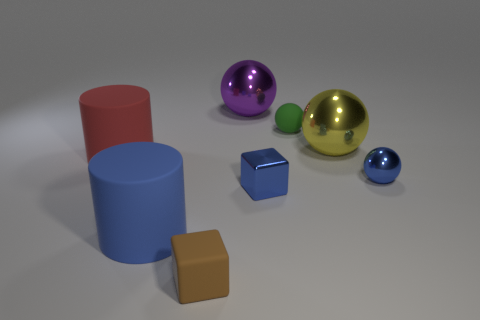Is the metal block the same color as the tiny metallic sphere?
Give a very brief answer. Yes. The big rubber object that is the same color as the shiny block is what shape?
Your answer should be compact. Cylinder. There is a yellow metal thing that is the same size as the purple thing; what shape is it?
Make the answer very short. Sphere. Are there fewer large purple things than big metallic balls?
Provide a short and direct response. Yes. Are there any blocks behind the large metallic object that is to the right of the tiny matte sphere?
Keep it short and to the point. No. There is a tiny brown thing that is made of the same material as the blue cylinder; what is its shape?
Offer a very short reply. Cube. Are there any other things of the same color as the matte block?
Provide a short and direct response. No. What material is the big yellow object that is the same shape as the large purple object?
Ensure brevity in your answer.  Metal. What number of other things are the same size as the red matte cylinder?
Your answer should be compact. 3. What is the size of the cube that is the same color as the tiny metal ball?
Your response must be concise. Small. 